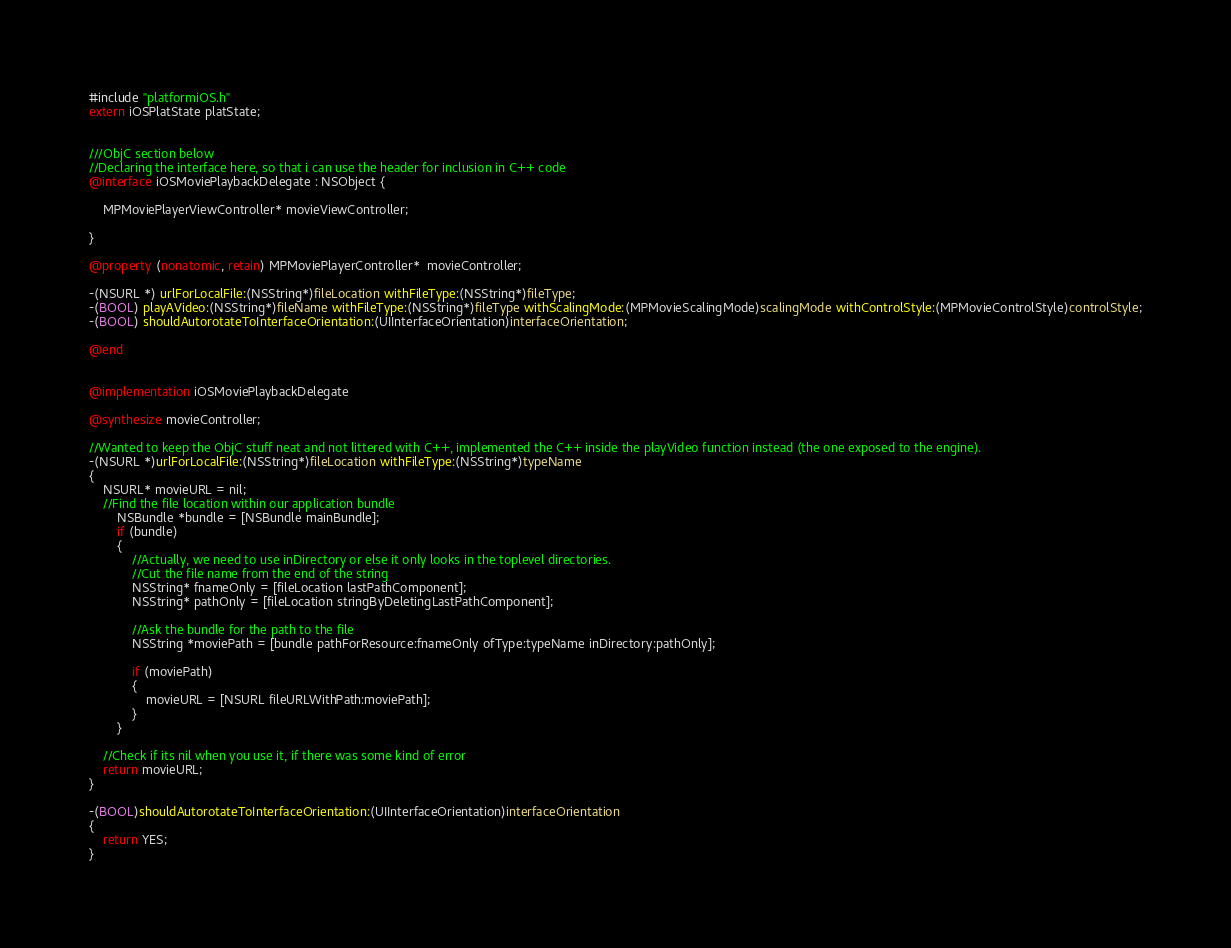<code> <loc_0><loc_0><loc_500><loc_500><_ObjectiveC_>#include "platformiOS.h"
extern iOSPlatState platState;


///ObjC section below
//Declaring the interface here, so that i can use the header for inclusion in C++ code
@interface iOSMoviePlaybackDelegate : NSObject {
	
	MPMoviePlayerViewController* movieViewController;
	
}

@property (nonatomic, retain) MPMoviePlayerController*  movieController;

-(NSURL *) urlForLocalFile:(NSString*)fileLocation withFileType:(NSString*)fileType;
-(BOOL) playAVideo:(NSString*)fileName withFileType:(NSString*)fileType withScalingMode:(MPMovieScalingMode)scalingMode withControlStyle:(MPMovieControlStyle)controlStyle;
-(BOOL) shouldAutorotateToInterfaceOrientation:(UIInterfaceOrientation)interfaceOrientation;

@end


@implementation iOSMoviePlaybackDelegate 

@synthesize movieController;

//Wanted to keep the ObjC stuff neat and not littered with C++, implemented the C++ inside the playVideo function instead (the one exposed to the engine).
-(NSURL *)urlForLocalFile:(NSString*)fileLocation withFileType:(NSString*)typeName
{
	NSURL* movieURL = nil;
	//Find the file location within our application bundle
        NSBundle *bundle = [NSBundle mainBundle];
        if (bundle)
        {
			//Actually, we need to use inDirectory or else it only looks in the toplevel directories.
			//Cut the file name from the end of the string
			NSString* fnameOnly = [fileLocation lastPathComponent];
			NSString* pathOnly = [fileLocation stringByDeletingLastPathComponent];
			
			//Ask the bundle for the path to the file
            NSString *moviePath = [bundle pathForResource:fnameOnly ofType:typeName inDirectory:pathOnly];
			
            if (moviePath)
            {
                movieURL = [NSURL fileURLWithPath:moviePath];
            }
        }
    
	//Check if its nil when you use it, if there was some kind of error
    return movieURL;
}

-(BOOL)shouldAutorotateToInterfaceOrientation:(UIInterfaceOrientation)interfaceOrientation 
{
	return YES;
}
</code> 